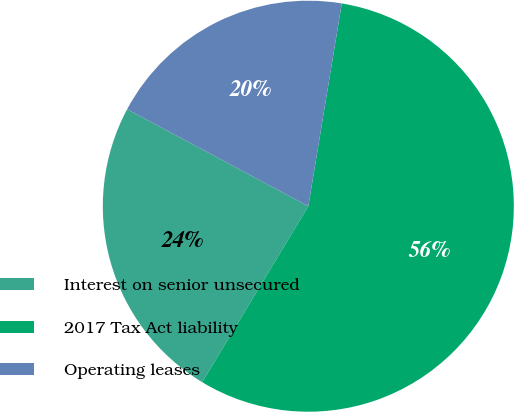<chart> <loc_0><loc_0><loc_500><loc_500><pie_chart><fcel>Interest on senior unsecured<fcel>2017 Tax Act liability<fcel>Operating leases<nl><fcel>24.19%<fcel>56.03%<fcel>19.78%<nl></chart> 